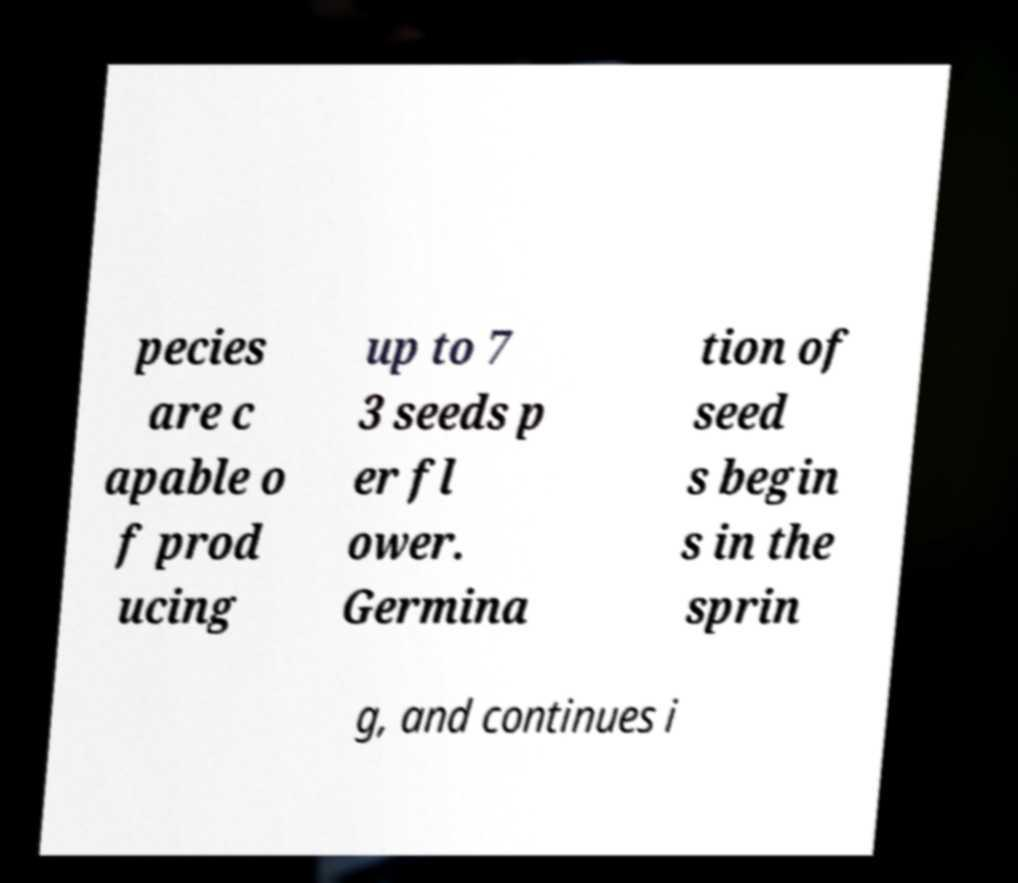There's text embedded in this image that I need extracted. Can you transcribe it verbatim? pecies are c apable o f prod ucing up to 7 3 seeds p er fl ower. Germina tion of seed s begin s in the sprin g, and continues i 